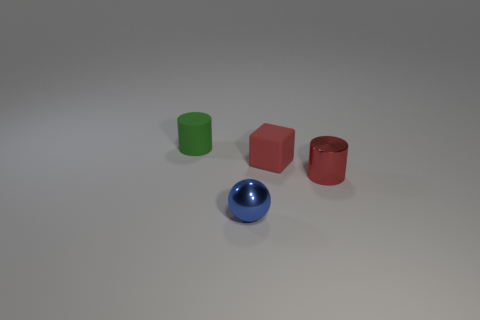Is there an object that stands out from the rest? Yes, the blue sphere stands out since it's the only spherical object among other geometric shapes, which are either cylinders or a block. 